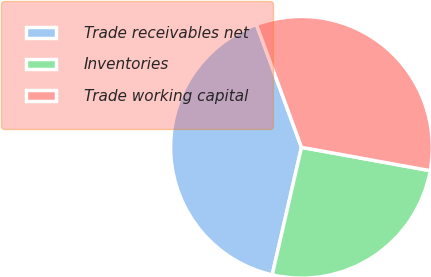Convert chart. <chart><loc_0><loc_0><loc_500><loc_500><pie_chart><fcel>Trade receivables net<fcel>Inventories<fcel>Trade working capital<nl><fcel>40.82%<fcel>25.73%<fcel>33.45%<nl></chart> 